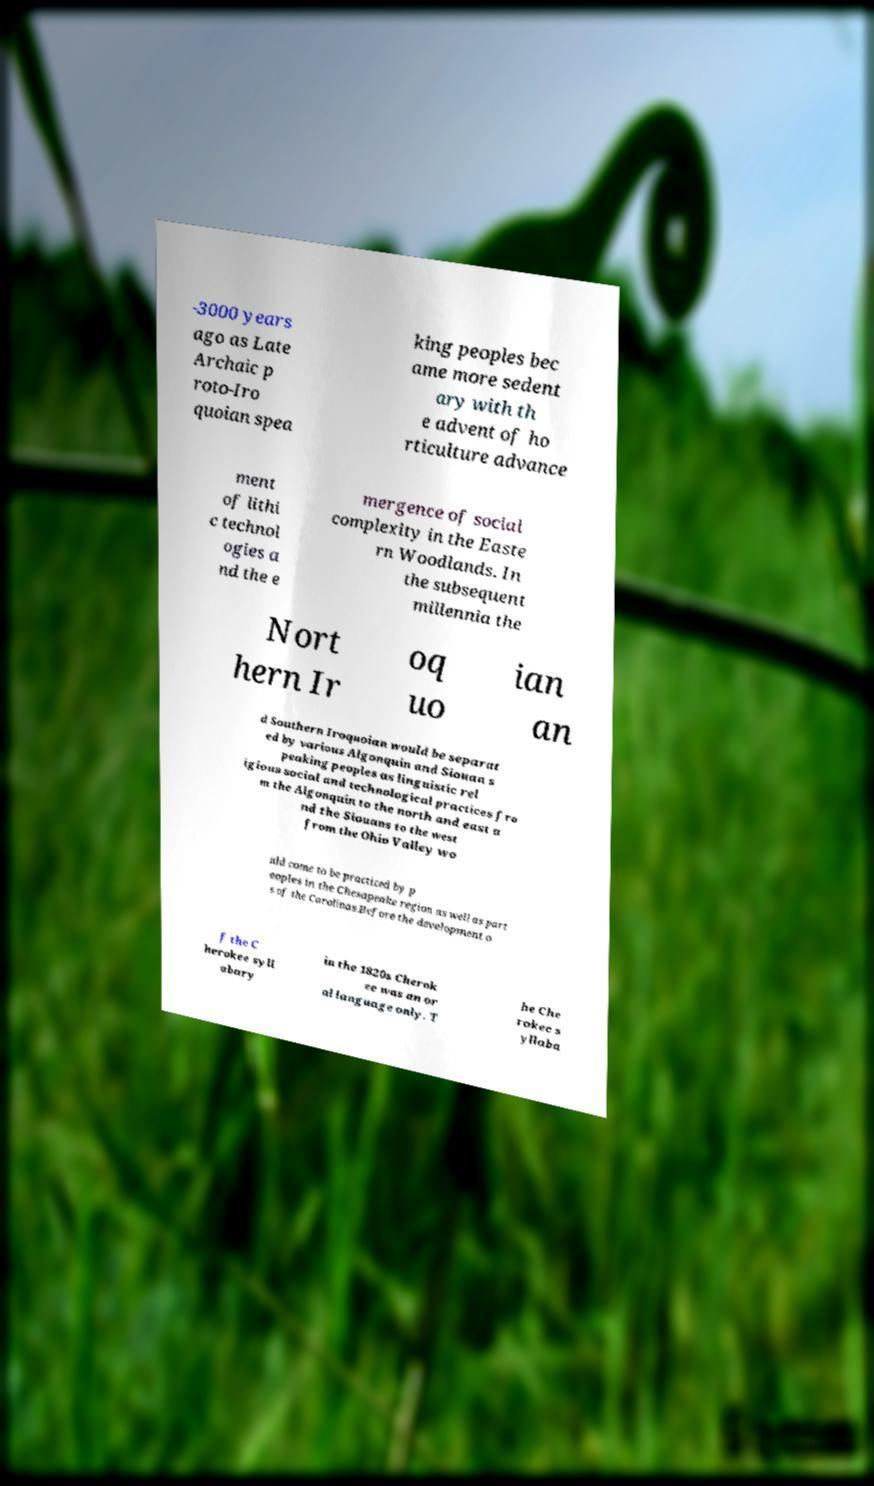There's text embedded in this image that I need extracted. Can you transcribe it verbatim? -3000 years ago as Late Archaic p roto-Iro quoian spea king peoples bec ame more sedent ary with th e advent of ho rticulture advance ment of lithi c technol ogies a nd the e mergence of social complexity in the Easte rn Woodlands. In the subsequent millennia the Nort hern Ir oq uo ian an d Southern Iroquoian would be separat ed by various Algonquin and Siouan s peaking peoples as linguistic rel igious social and technological practices fro m the Algonquin to the north and east a nd the Siouans to the west from the Ohio Valley wo uld come to be practiced by p eoples in the Chesapeake region as well as part s of the Carolinas.Before the development o f the C herokee syll abary in the 1820s Cherok ee was an or al language only. T he Che rokee s yllaba 